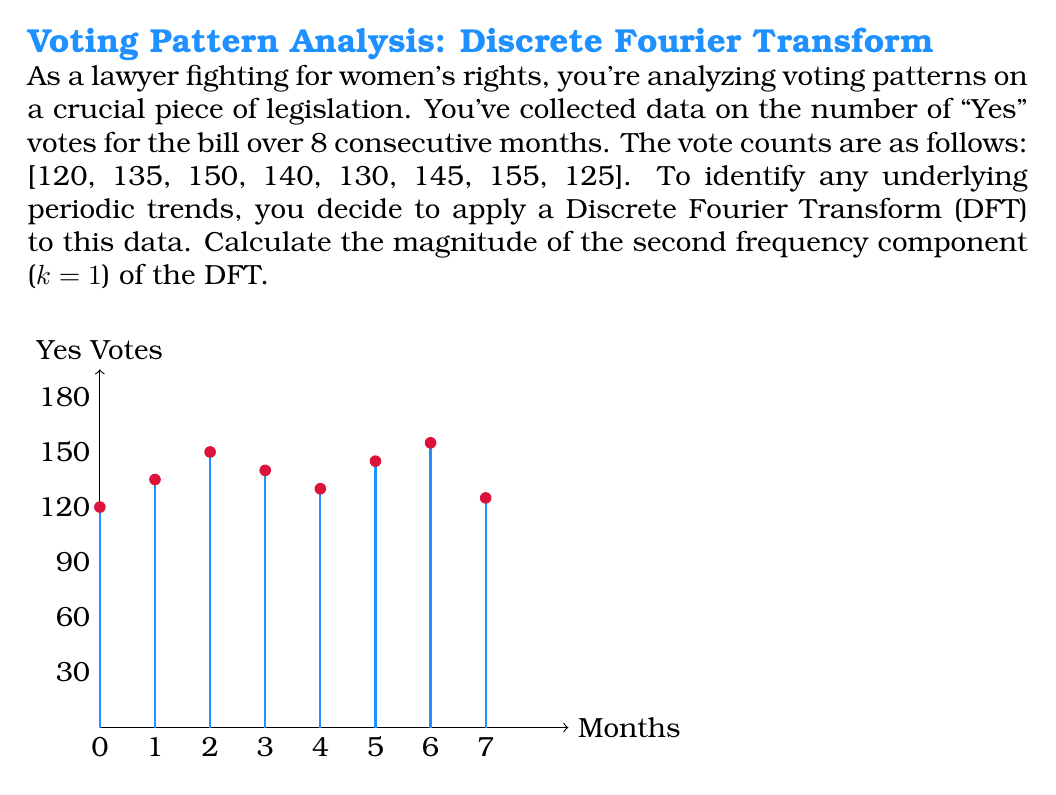Give your solution to this math problem. To solve this problem, we'll follow these steps:

1) The Discrete Fourier Transform (DFT) is given by the formula:

   $$X_k = \sum_{n=0}^{N-1} x_n e^{-i2\pi kn/N}$$

   where $X_k$ is the k-th frequency component, $x_n$ is the n-th data point, N is the total number of data points, and $i$ is the imaginary unit.

2) We're asked to calculate the magnitude of the second frequency component (k=1). We'll need to calculate both the real and imaginary parts:

   $$X_1 = \sum_{n=0}^{7} x_n e^{-i2\pi n/8}$$

3) Expanding this:

   $$X_1 = 120e^{-i2\pi(0)/8} + 135e^{-i2\pi(1)/8} + 150e^{-i2\pi(2)/8} + 140e^{-i2\pi(3)/8} + 130e^{-i2\pi(4)/8} + 145e^{-i2\pi(5)/8} + 155e^{-i2\pi(6)/8} + 125e^{-i2\pi(7)/8}$$

4) Using Euler's formula, $e^{-i\theta} = \cos\theta - i\sin\theta$, we can separate real and imaginary parts:

   Real part:
   $$Re(X_1) = 120 + 135\cos(\frac{\pi}{4}) + 150\cos(\frac{\pi}{2}) + 140\cos(\frac{3\pi}{4}) + 130\cos(\pi) + 145\cos(\frac{5\pi}{4}) + 155\cos(\frac{3\pi}{2}) + 125\cos(\frac{7\pi}{4})$$

   Imaginary part:
   $$Im(X_1) = -135\sin(\frac{\pi}{4}) - 150\sin(\frac{\pi}{2}) - 140\sin(\frac{3\pi}{4}) - 130\sin(\pi) - 145\sin(\frac{5\pi}{4}) - 155\sin(\frac{3\pi}{2}) - 125\sin(\frac{7\pi}{4})$$

5) Calculating these values:

   $$Re(X_1) \approx 27.3$$
   $$Im(X_1) \approx -25.9$$

6) The magnitude is given by $\sqrt{Re(X_1)^2 + Im(X_1)^2}$:

   $$|X_1| = \sqrt{27.3^2 + (-25.9)^2} \approx 37.6$$
Answer: 37.6 